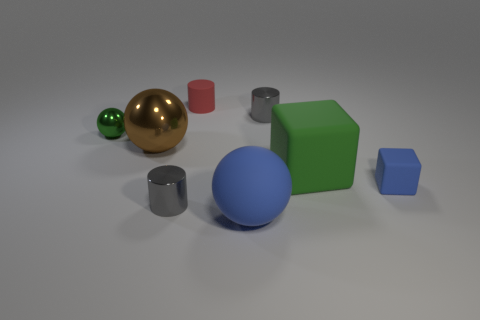There is a blue rubber sphere that is in front of the small blue rubber block; how big is it?
Provide a succinct answer. Large. Is there a small matte cylinder that is to the right of the tiny cylinder that is in front of the big rubber cube?
Ensure brevity in your answer.  Yes. There is a large rubber object in front of the blue block; is its color the same as the small object right of the large cube?
Offer a terse response. Yes. The small matte cylinder is what color?
Your response must be concise. Red. Are there any other things of the same color as the big metallic thing?
Provide a short and direct response. No. The small metallic thing that is both behind the brown sphere and to the right of the brown shiny object is what color?
Your answer should be very brief. Gray. Do the brown metallic object on the left side of the green block and the blue matte block have the same size?
Provide a short and direct response. No. Are there more objects in front of the tiny red cylinder than cyan metal objects?
Keep it short and to the point. Yes. Is the brown object the same shape as the green metal thing?
Your answer should be very brief. Yes. The red matte cylinder is what size?
Offer a very short reply. Small. 